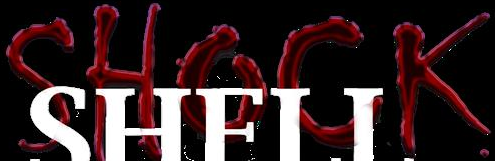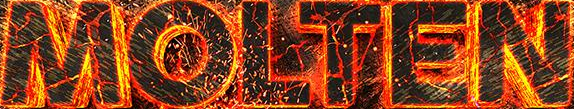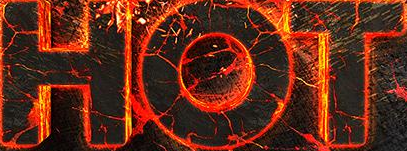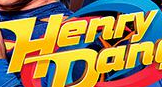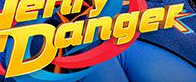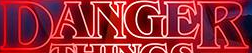What text is displayed in these images sequentially, separated by a semicolon? SHOCK; MOLTEN; HOT; Henry; Danger; DANGER 